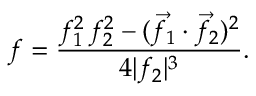Convert formula to latex. <formula><loc_0><loc_0><loc_500><loc_500>f = { \frac { f _ { 1 } ^ { 2 } \, f _ { 2 } ^ { 2 } - ( { \vec { f } } _ { 1 } \cdot { \vec { f } } _ { 2 } ) ^ { 2 } } { 4 | f _ { 2 } | ^ { 3 } } } .</formula> 